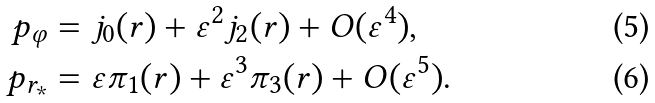Convert formula to latex. <formula><loc_0><loc_0><loc_500><loc_500>p _ { \varphi } & = j _ { 0 } ( r ) + \varepsilon ^ { 2 } j _ { 2 } ( r ) + O ( \varepsilon ^ { 4 } ) , \\ p _ { r _ { * } } & = \varepsilon \pi _ { 1 } ( r ) + \varepsilon ^ { 3 } \pi _ { 3 } ( r ) + O ( \varepsilon ^ { 5 } ) .</formula> 